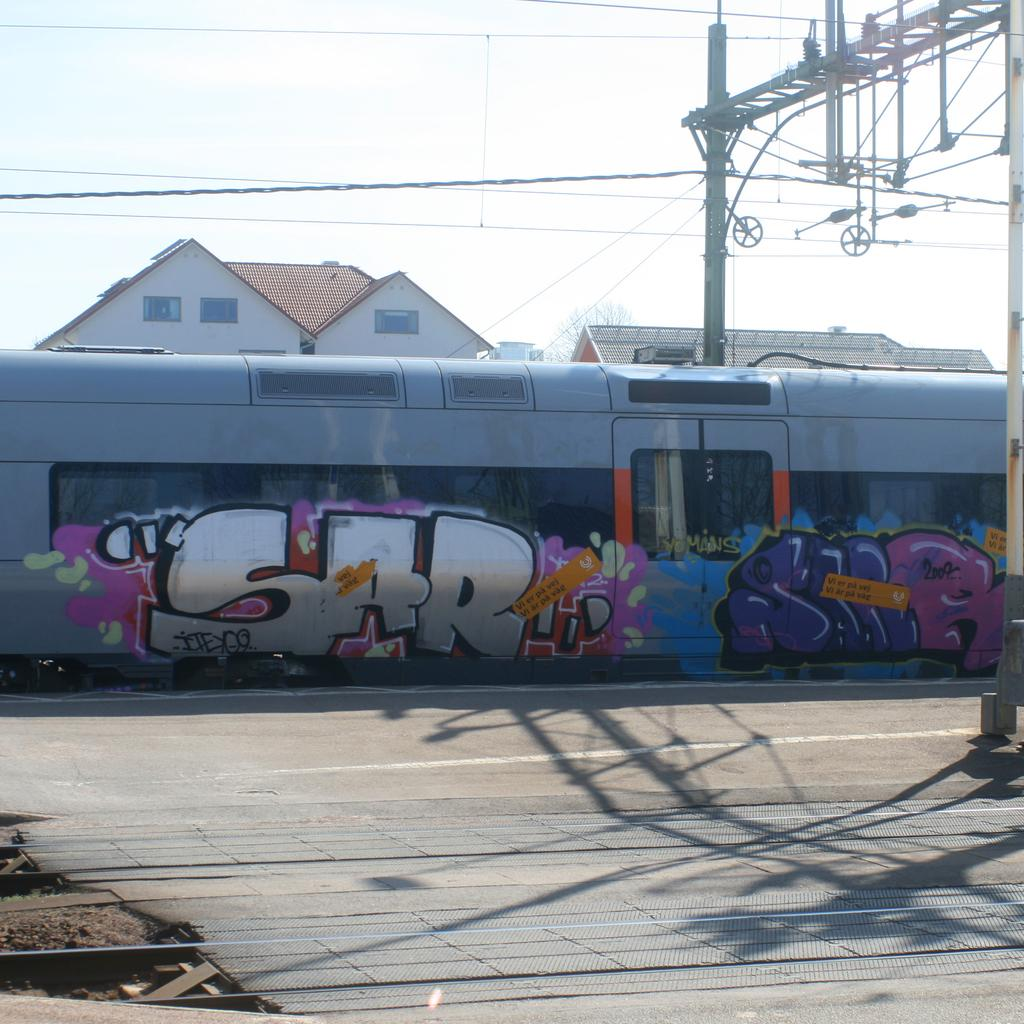What is the subject of the graffiti on the train in the image? The facts provided do not specify the content of the graffiti. What else can be seen in the image besides the graffiti on the train? There are cables visible in the image. What is visible in the background of the image? There are houses in the background of the image. What feature do the houses have? The houses have windows. What type of laborer is depicted in the graffiti on the train? There is no laborer depicted in the graffiti on the train, as the content of the graffiti is not specified in the provided facts. How many carriages are attached to the train in the image? The facts provided do not mention the number of carriages attached to the train. 